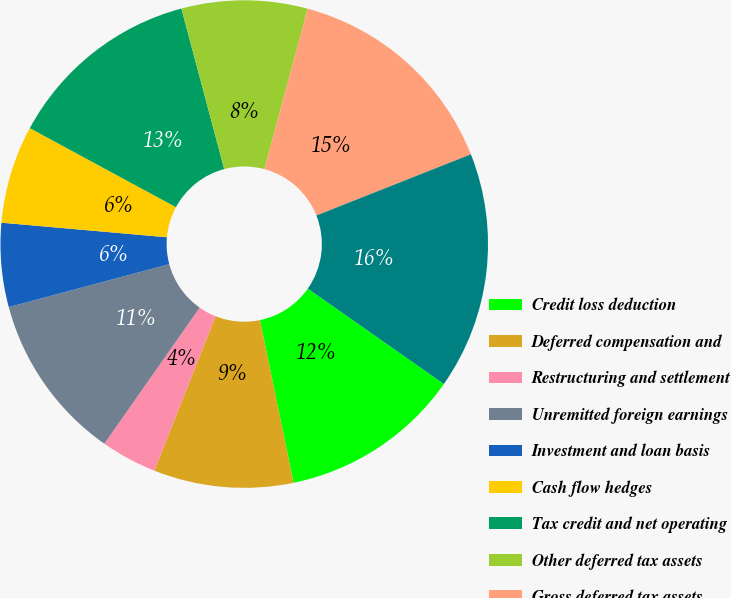Convert chart. <chart><loc_0><loc_0><loc_500><loc_500><pie_chart><fcel>Credit loss deduction<fcel>Deferred compensation and<fcel>Restructuring and settlement<fcel>Unremitted foreign earnings<fcel>Investment and loan basis<fcel>Cash flow hedges<fcel>Tax credit and net operating<fcel>Other deferred tax assets<fcel>Gross deferred tax assets<fcel>Deferred tax assets after<nl><fcel>12.03%<fcel>9.26%<fcel>3.71%<fcel>11.11%<fcel>5.56%<fcel>6.49%<fcel>12.96%<fcel>8.34%<fcel>14.81%<fcel>15.73%<nl></chart> 